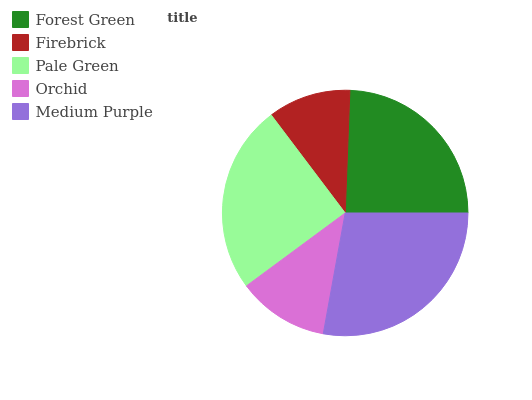Is Firebrick the minimum?
Answer yes or no. Yes. Is Medium Purple the maximum?
Answer yes or no. Yes. Is Pale Green the minimum?
Answer yes or no. No. Is Pale Green the maximum?
Answer yes or no. No. Is Pale Green greater than Firebrick?
Answer yes or no. Yes. Is Firebrick less than Pale Green?
Answer yes or no. Yes. Is Firebrick greater than Pale Green?
Answer yes or no. No. Is Pale Green less than Firebrick?
Answer yes or no. No. Is Forest Green the high median?
Answer yes or no. Yes. Is Forest Green the low median?
Answer yes or no. Yes. Is Pale Green the high median?
Answer yes or no. No. Is Medium Purple the low median?
Answer yes or no. No. 